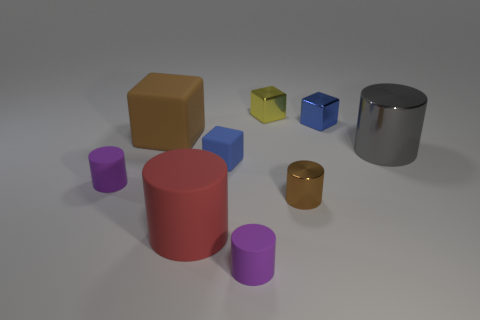There is a purple object that is on the left side of the brown rubber object; what number of small cylinders are in front of it?
Provide a succinct answer. 2. There is a yellow shiny block; is it the same size as the blue cube that is in front of the small blue shiny block?
Make the answer very short. Yes. Is the gray cylinder the same size as the red rubber object?
Your answer should be compact. Yes. Are there any purple cylinders of the same size as the blue metallic thing?
Your answer should be very brief. Yes. What material is the big thing in front of the big gray metal cylinder?
Keep it short and to the point. Rubber. What color is the large cylinder that is the same material as the large brown thing?
Keep it short and to the point. Red. What number of metallic things are things or red things?
Ensure brevity in your answer.  4. There is a brown object that is the same size as the yellow thing; what shape is it?
Give a very brief answer. Cylinder. How many objects are small rubber cylinders that are in front of the big red thing or purple matte cylinders that are in front of the brown cylinder?
Offer a very short reply. 1. What material is the red cylinder that is the same size as the brown matte block?
Offer a terse response. Rubber. 